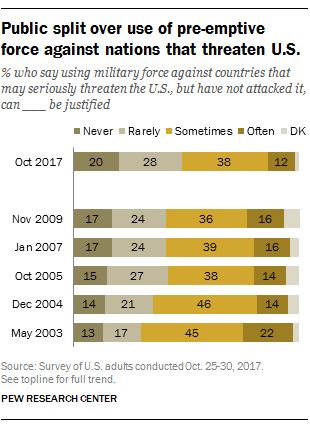Highlight a few significant elements in this photo. In October 2017, the value for the "sometimes" bar was 0.38. Sometimes, the widest bar remains during every time period. 